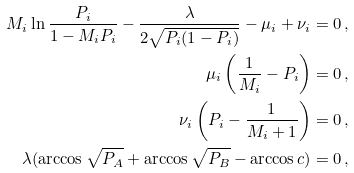Convert formula to latex. <formula><loc_0><loc_0><loc_500><loc_500>M _ { i } \ln \frac { P _ { i } } { 1 - M _ { i } P _ { i } } - \frac { \lambda } { 2 \sqrt { P _ { i } ( 1 - P _ { i } ) } } - \mu _ { i } + \nu _ { i } = 0 \, , \\ \mu _ { i } \left ( \frac { 1 } { M _ { i } } - P _ { i } \right ) = 0 \, , \\ \nu _ { i } \left ( P _ { i } - \frac { 1 } { M _ { i } + 1 } \right ) = 0 \, , \\ \lambda ( \arccos \sqrt { P _ { A } } + \arccos \sqrt { P _ { B } } - \arccos c ) = 0 \, ,</formula> 